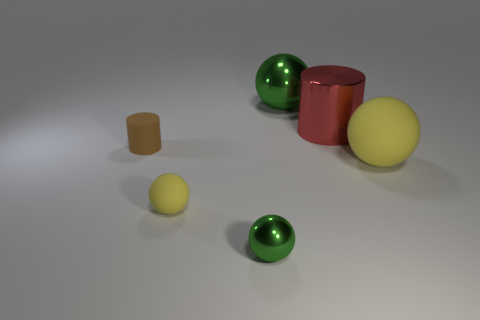Subtract 1 spheres. How many spheres are left? 3 Subtract all brown spheres. Subtract all green cubes. How many spheres are left? 4 Add 1 small metallic things. How many objects exist? 7 Subtract all balls. How many objects are left? 2 Add 2 purple rubber cubes. How many purple rubber cubes exist? 2 Subtract 2 yellow balls. How many objects are left? 4 Subtract all cyan rubber spheres. Subtract all tiny rubber cylinders. How many objects are left? 5 Add 4 red cylinders. How many red cylinders are left? 5 